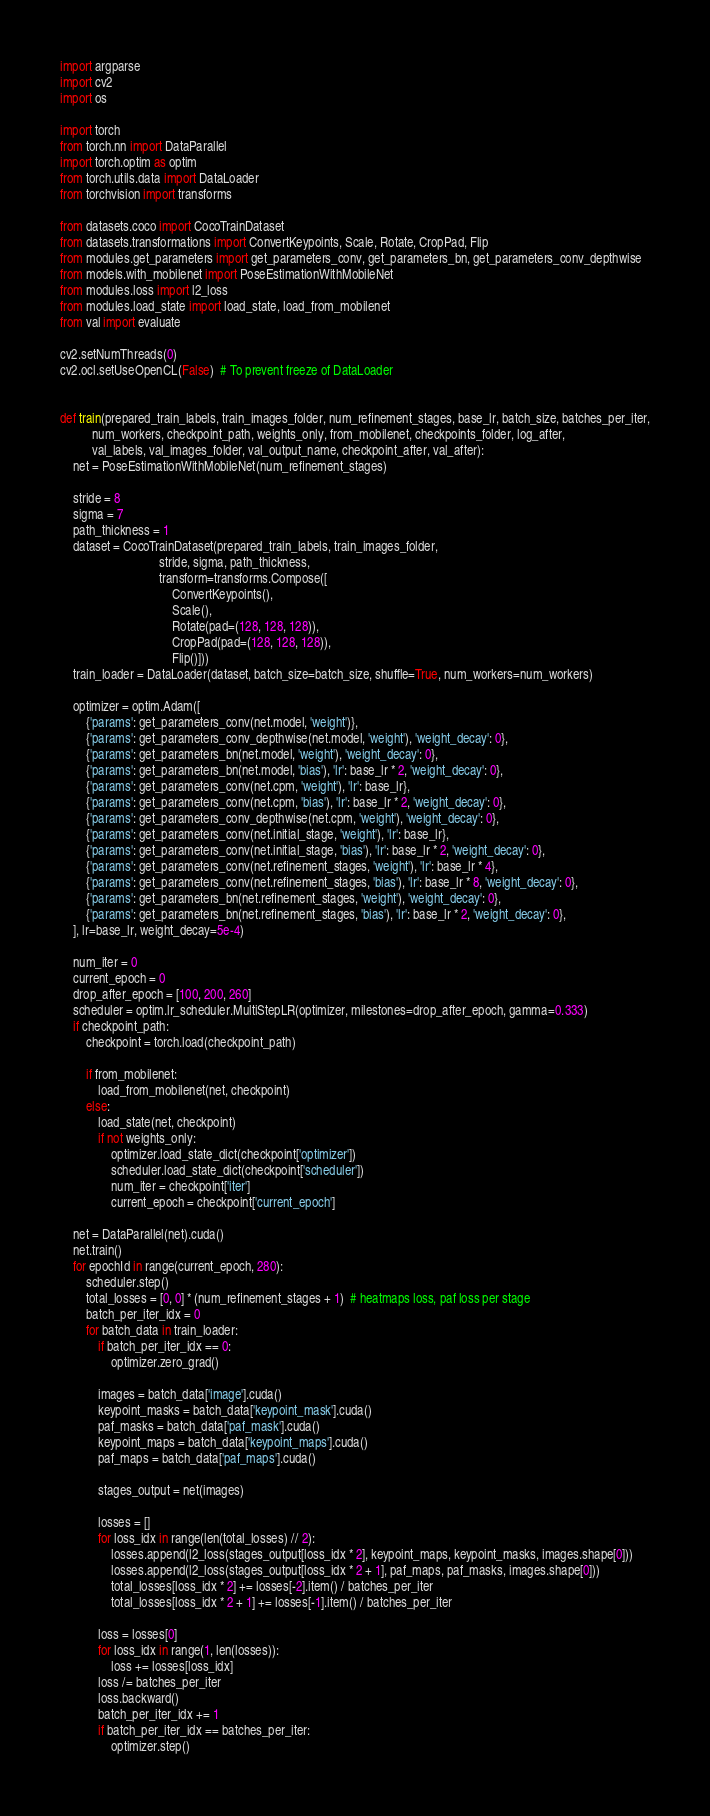Convert code to text. <code><loc_0><loc_0><loc_500><loc_500><_Python_>import argparse
import cv2
import os

import torch
from torch.nn import DataParallel
import torch.optim as optim
from torch.utils.data import DataLoader
from torchvision import transforms

from datasets.coco import CocoTrainDataset
from datasets.transformations import ConvertKeypoints, Scale, Rotate, CropPad, Flip
from modules.get_parameters import get_parameters_conv, get_parameters_bn, get_parameters_conv_depthwise
from models.with_mobilenet import PoseEstimationWithMobileNet
from modules.loss import l2_loss
from modules.load_state import load_state, load_from_mobilenet
from val import evaluate

cv2.setNumThreads(0)
cv2.ocl.setUseOpenCL(False)  # To prevent freeze of DataLoader


def train(prepared_train_labels, train_images_folder, num_refinement_stages, base_lr, batch_size, batches_per_iter,
          num_workers, checkpoint_path, weights_only, from_mobilenet, checkpoints_folder, log_after,
          val_labels, val_images_folder, val_output_name, checkpoint_after, val_after):
    net = PoseEstimationWithMobileNet(num_refinement_stages)

    stride = 8
    sigma = 7
    path_thickness = 1
    dataset = CocoTrainDataset(prepared_train_labels, train_images_folder,
                               stride, sigma, path_thickness,
                               transform=transforms.Compose([
                                   ConvertKeypoints(),
                                   Scale(),
                                   Rotate(pad=(128, 128, 128)),
                                   CropPad(pad=(128, 128, 128)),
                                   Flip()]))
    train_loader = DataLoader(dataset, batch_size=batch_size, shuffle=True, num_workers=num_workers)

    optimizer = optim.Adam([
        {'params': get_parameters_conv(net.model, 'weight')},
        {'params': get_parameters_conv_depthwise(net.model, 'weight'), 'weight_decay': 0},
        {'params': get_parameters_bn(net.model, 'weight'), 'weight_decay': 0},
        {'params': get_parameters_bn(net.model, 'bias'), 'lr': base_lr * 2, 'weight_decay': 0},
        {'params': get_parameters_conv(net.cpm, 'weight'), 'lr': base_lr},
        {'params': get_parameters_conv(net.cpm, 'bias'), 'lr': base_lr * 2, 'weight_decay': 0},
        {'params': get_parameters_conv_depthwise(net.cpm, 'weight'), 'weight_decay': 0},
        {'params': get_parameters_conv(net.initial_stage, 'weight'), 'lr': base_lr},
        {'params': get_parameters_conv(net.initial_stage, 'bias'), 'lr': base_lr * 2, 'weight_decay': 0},
        {'params': get_parameters_conv(net.refinement_stages, 'weight'), 'lr': base_lr * 4},
        {'params': get_parameters_conv(net.refinement_stages, 'bias'), 'lr': base_lr * 8, 'weight_decay': 0},
        {'params': get_parameters_bn(net.refinement_stages, 'weight'), 'weight_decay': 0},
        {'params': get_parameters_bn(net.refinement_stages, 'bias'), 'lr': base_lr * 2, 'weight_decay': 0},
    ], lr=base_lr, weight_decay=5e-4)

    num_iter = 0
    current_epoch = 0
    drop_after_epoch = [100, 200, 260]
    scheduler = optim.lr_scheduler.MultiStepLR(optimizer, milestones=drop_after_epoch, gamma=0.333)
    if checkpoint_path:
        checkpoint = torch.load(checkpoint_path)

        if from_mobilenet:
            load_from_mobilenet(net, checkpoint)
        else:
            load_state(net, checkpoint)
            if not weights_only:
                optimizer.load_state_dict(checkpoint['optimizer'])
                scheduler.load_state_dict(checkpoint['scheduler'])
                num_iter = checkpoint['iter']
                current_epoch = checkpoint['current_epoch']

    net = DataParallel(net).cuda()
    net.train()
    for epochId in range(current_epoch, 280):
        scheduler.step()
        total_losses = [0, 0] * (num_refinement_stages + 1)  # heatmaps loss, paf loss per stage
        batch_per_iter_idx = 0
        for batch_data in train_loader:
            if batch_per_iter_idx == 0:
                optimizer.zero_grad()

            images = batch_data['image'].cuda()
            keypoint_masks = batch_data['keypoint_mask'].cuda()
            paf_masks = batch_data['paf_mask'].cuda()
            keypoint_maps = batch_data['keypoint_maps'].cuda()
            paf_maps = batch_data['paf_maps'].cuda()

            stages_output = net(images)

            losses = []
            for loss_idx in range(len(total_losses) // 2):
                losses.append(l2_loss(stages_output[loss_idx * 2], keypoint_maps, keypoint_masks, images.shape[0]))
                losses.append(l2_loss(stages_output[loss_idx * 2 + 1], paf_maps, paf_masks, images.shape[0]))
                total_losses[loss_idx * 2] += losses[-2].item() / batches_per_iter
                total_losses[loss_idx * 2 + 1] += losses[-1].item() / batches_per_iter

            loss = losses[0]
            for loss_idx in range(1, len(losses)):
                loss += losses[loss_idx]
            loss /= batches_per_iter
            loss.backward()
            batch_per_iter_idx += 1
            if batch_per_iter_idx == batches_per_iter:
                optimizer.step()</code> 